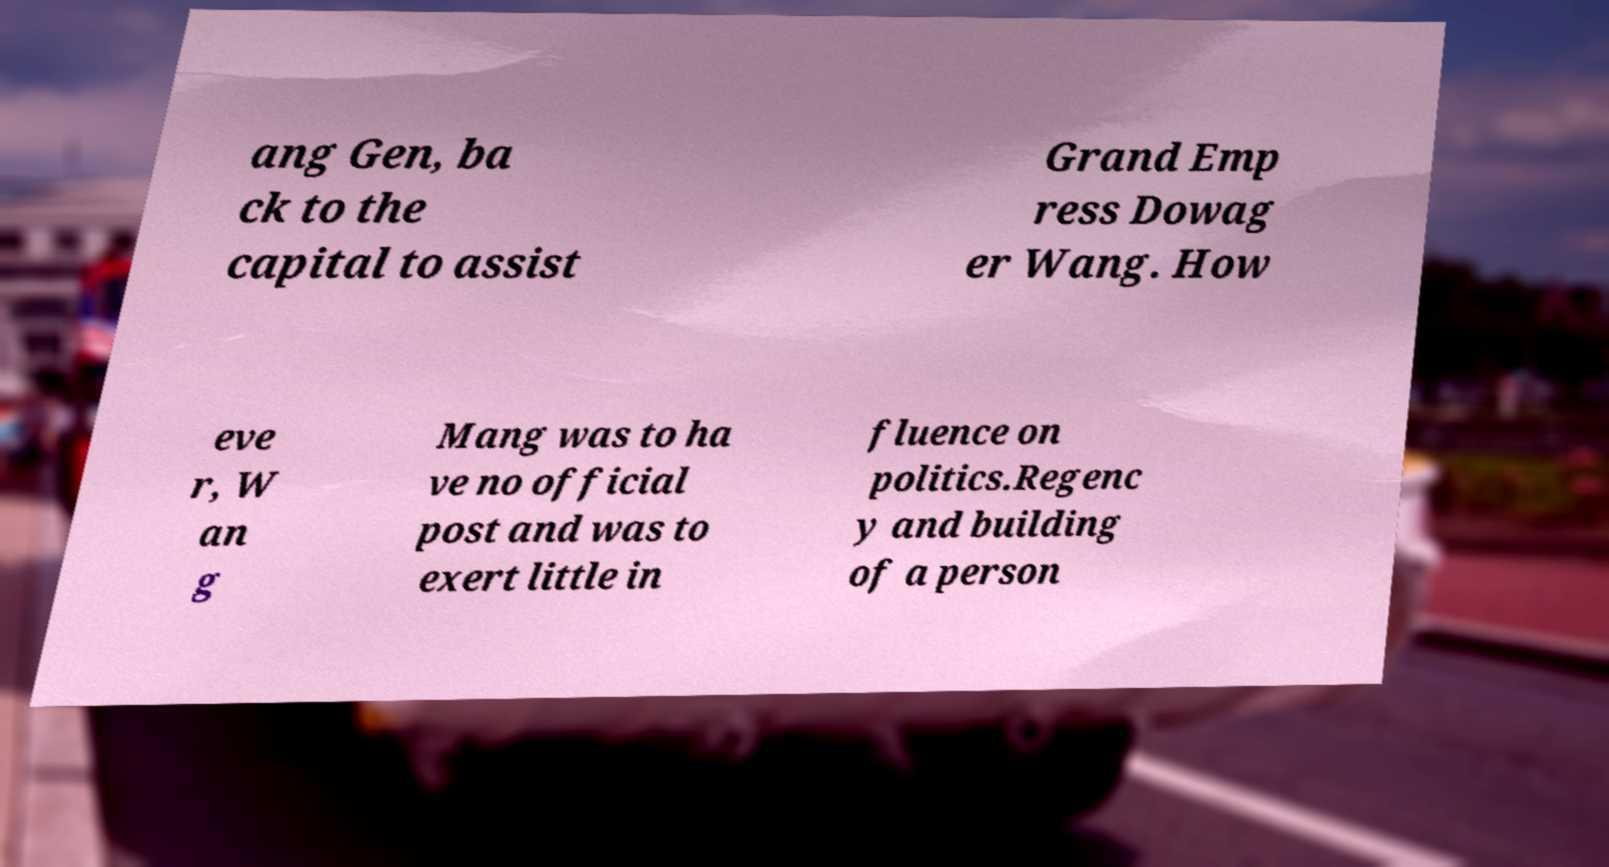For documentation purposes, I need the text within this image transcribed. Could you provide that? ang Gen, ba ck to the capital to assist Grand Emp ress Dowag er Wang. How eve r, W an g Mang was to ha ve no official post and was to exert little in fluence on politics.Regenc y and building of a person 